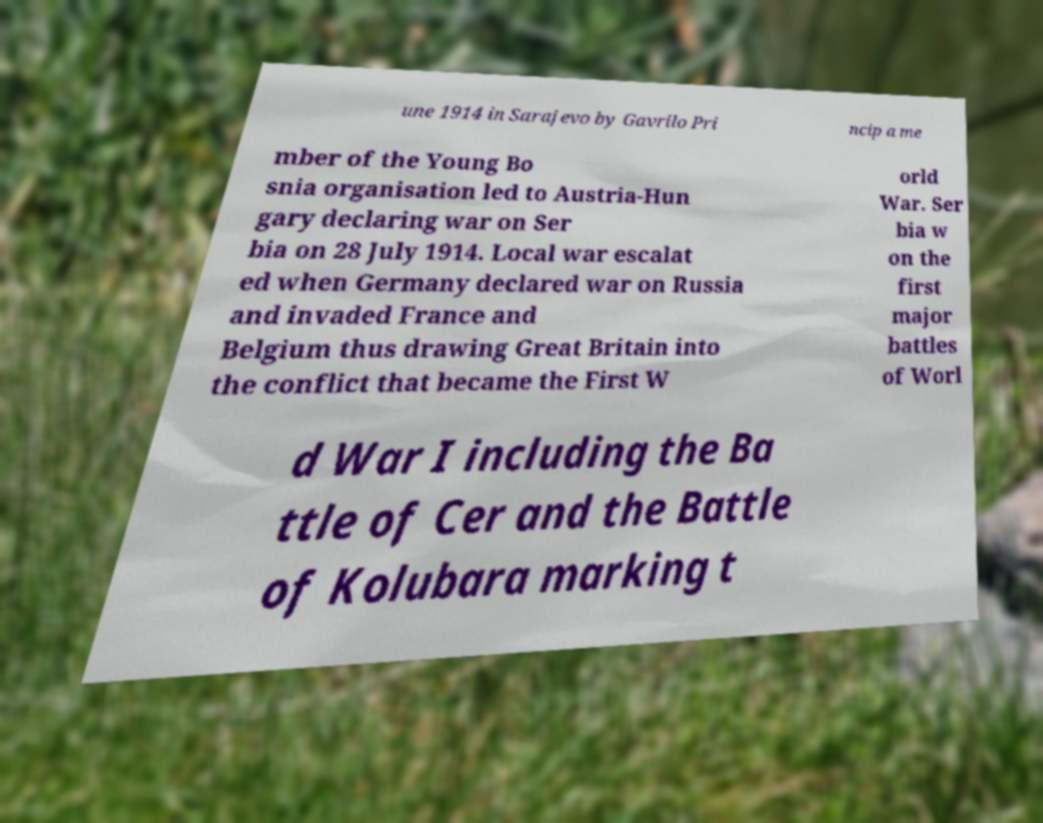I need the written content from this picture converted into text. Can you do that? une 1914 in Sarajevo by Gavrilo Pri ncip a me mber of the Young Bo snia organisation led to Austria-Hun gary declaring war on Ser bia on 28 July 1914. Local war escalat ed when Germany declared war on Russia and invaded France and Belgium thus drawing Great Britain into the conflict that became the First W orld War. Ser bia w on the first major battles of Worl d War I including the Ba ttle of Cer and the Battle of Kolubara marking t 